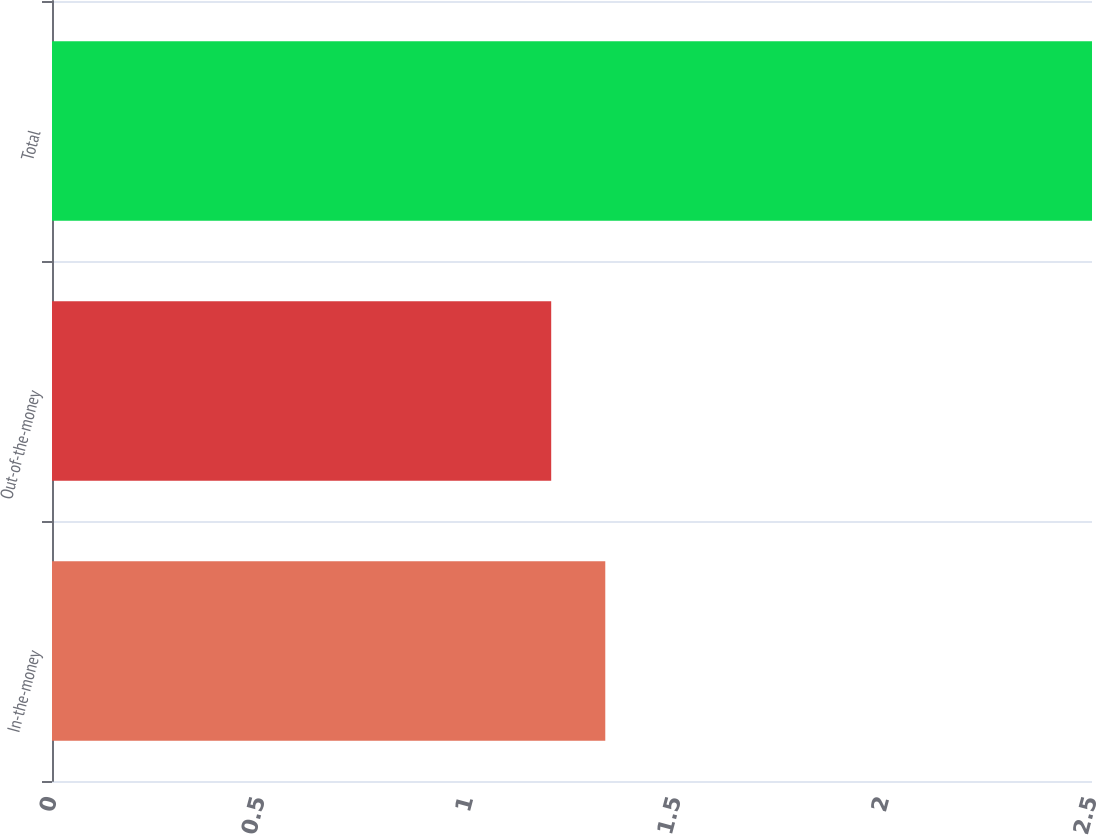<chart> <loc_0><loc_0><loc_500><loc_500><bar_chart><fcel>In-the-money<fcel>Out-of-the-money<fcel>Total<nl><fcel>1.33<fcel>1.2<fcel>2.5<nl></chart> 